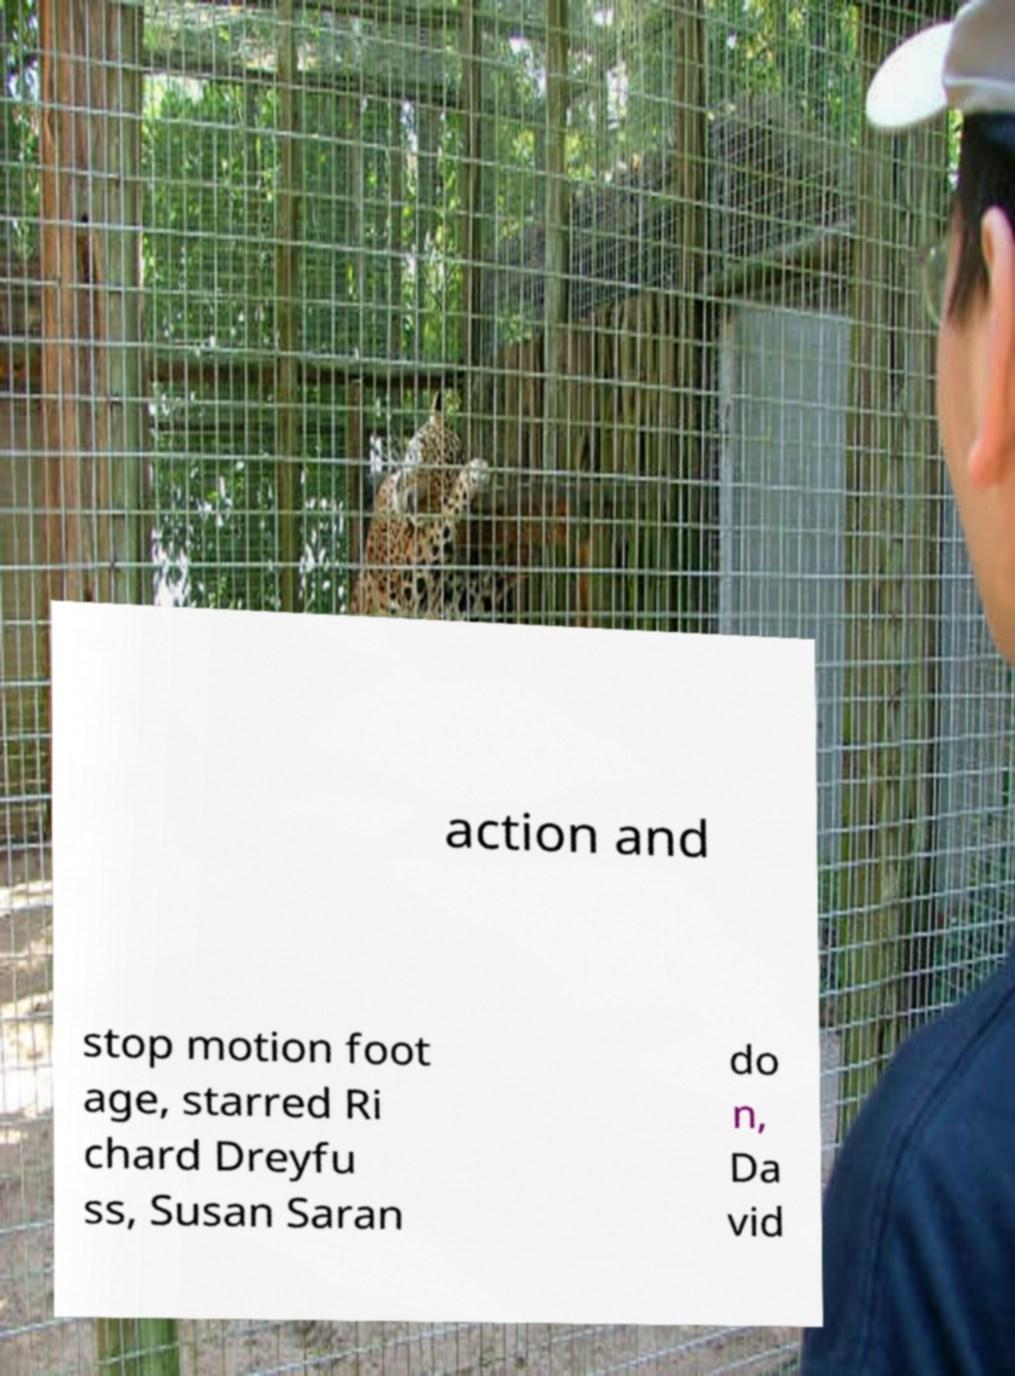I need the written content from this picture converted into text. Can you do that? action and stop motion foot age, starred Ri chard Dreyfu ss, Susan Saran do n, Da vid 